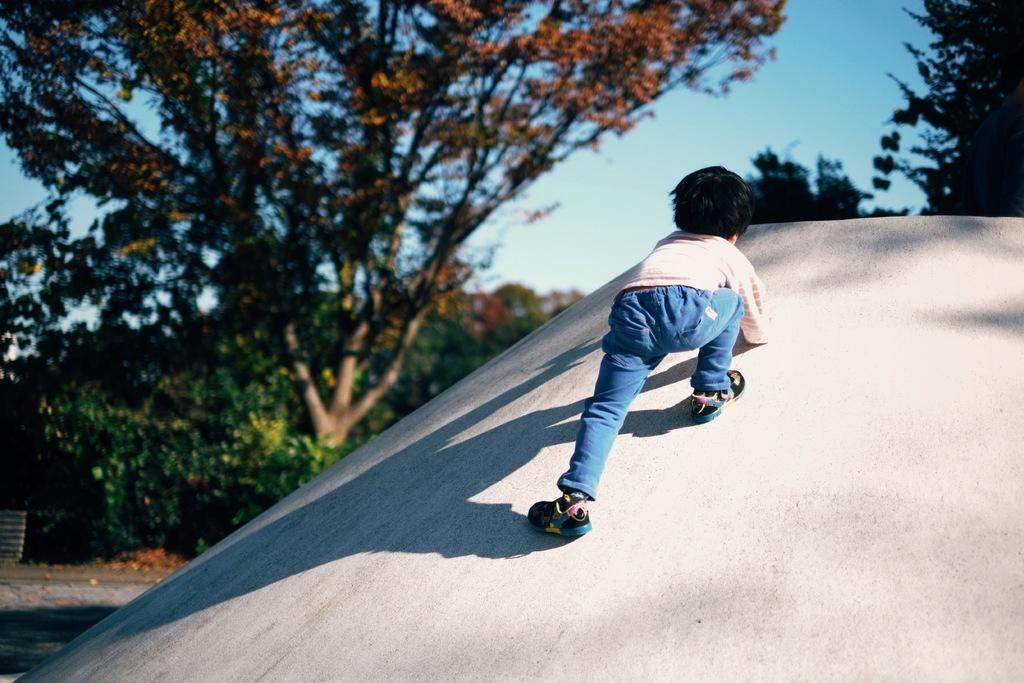What is the main subject of the image? There is a child in the image. What is the child doing in the image? The child is climbing on a slanting surface. What can be seen in the background of the image? There are trees and the sky visible in the background of the image. How many wishes does the child have written on the slanting surface in the image? There is no indication in the image that the child has written any wishes on the slanting surface. 